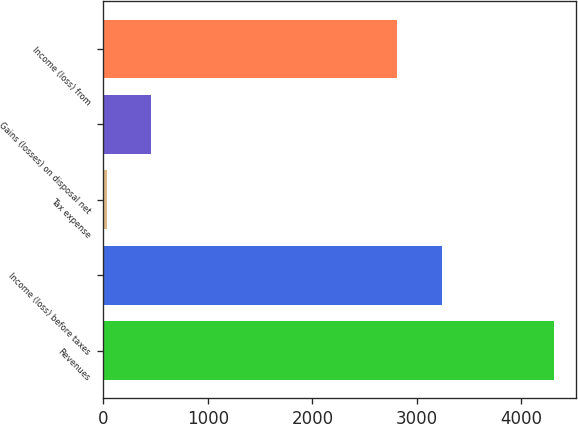Convert chart to OTSL. <chart><loc_0><loc_0><loc_500><loc_500><bar_chart><fcel>Revenues<fcel>Income (loss) before taxes<fcel>Tax expense<fcel>Gains (losses) on disposal net<fcel>Income (loss) from<nl><fcel>4311<fcel>3237<fcel>31<fcel>459<fcel>2809<nl></chart> 